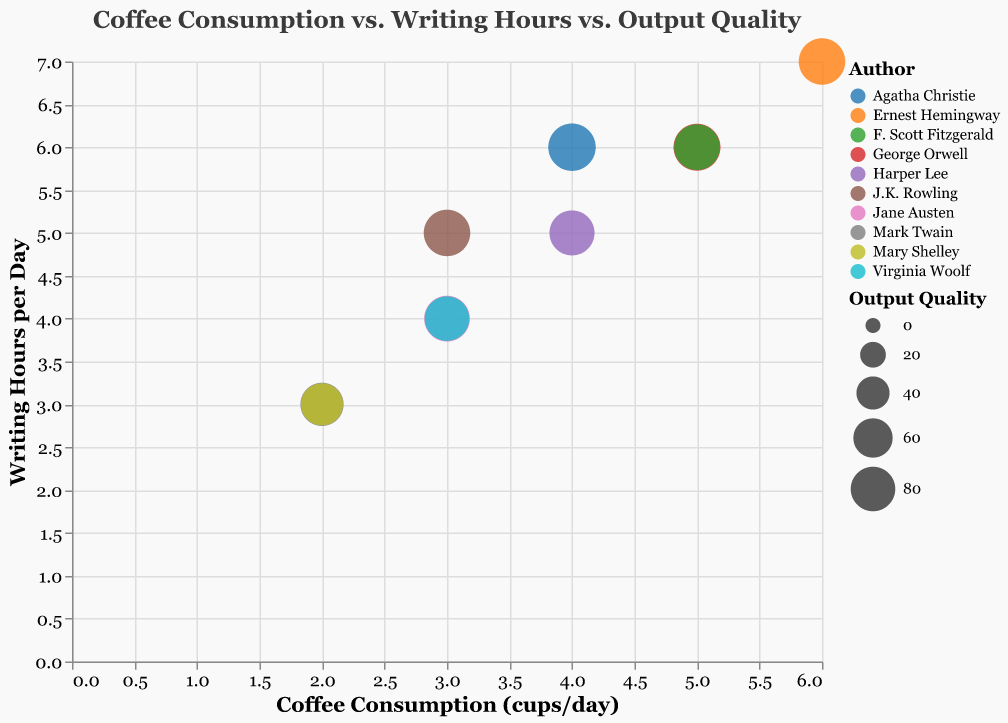Which author consumes the most coffee daily? The author with the highest data point on the x-axis represents the maximum coffee consumption. Ernest Hemingway drinks 6 cups/day.
Answer: Ernest Hemingway How many hours per day does George Orwell spend writing? Locate George Orwell on the legend and find his corresponding Y-axis value, which shows writing hours per day.
Answer: 6 Which author has the highest output quality? The bubble size represents output quality; the largest bubble belongs to Agatha Christie with an output quality of 92.
Answer: Agatha Christie What's the average writing hours per day among all authors? Sum the writing hours per day for all authors (4 + 6 + 3 + 5 + 7 + 4 + 6 + 3 + 5 + 6 = 49) and divide by the number of authors (10). 49/10 = 4.9
Answer: 4.9 Which author had the lowest output quality? Locate the smallest bubble, corresponding to Mary Shelley, whose output quality is 70.
Answer: Mary Shelley Is there a positive correlation between writing hours and output quality? Observe the trend that more writing hours tend to correspond with larger bubble sizes (higher quality).
Answer: Yes How many authors drink 3 cups of coffee per day? Count the number of bubbles aligned with the 3 cups/day mark on the x-axis. There are three authors: Jane Austen, Virginia Woolf, and J.K. Rowling.
Answer: 3 Which author writes for 6 hours a day and what is their coffee consumption? Locate the 6 hours/day on the Y-axis and find corresponding points on the X-axis and legend, leading to George Orwell (5 cups/day) and Agatha Christie (4 cups/day).
Answer: George Orwell (5 cups/day) and Agatha Christie (4 cups/day) What is the total output quality of authors who drink 2 cups of coffee per day? Identify authors with 2 cups/day (Mark Twain and Mary Shelley), then sum their output qualities: 75 + 70 = 145.
Answer: 145 Is there an author who writes for fewer hours per day but has a higher output quality than another author who writes more hours? Compare all authors' writing hours and output quality. J.K. Rowling writes for 5 hours/day with a higher output quality (88) than F. Scott Fitzgerald, who writes for 6 hours/day with an output quality of 85.
Answer: Yes, J.K. Rowling and F. Scott Fitzgerald 